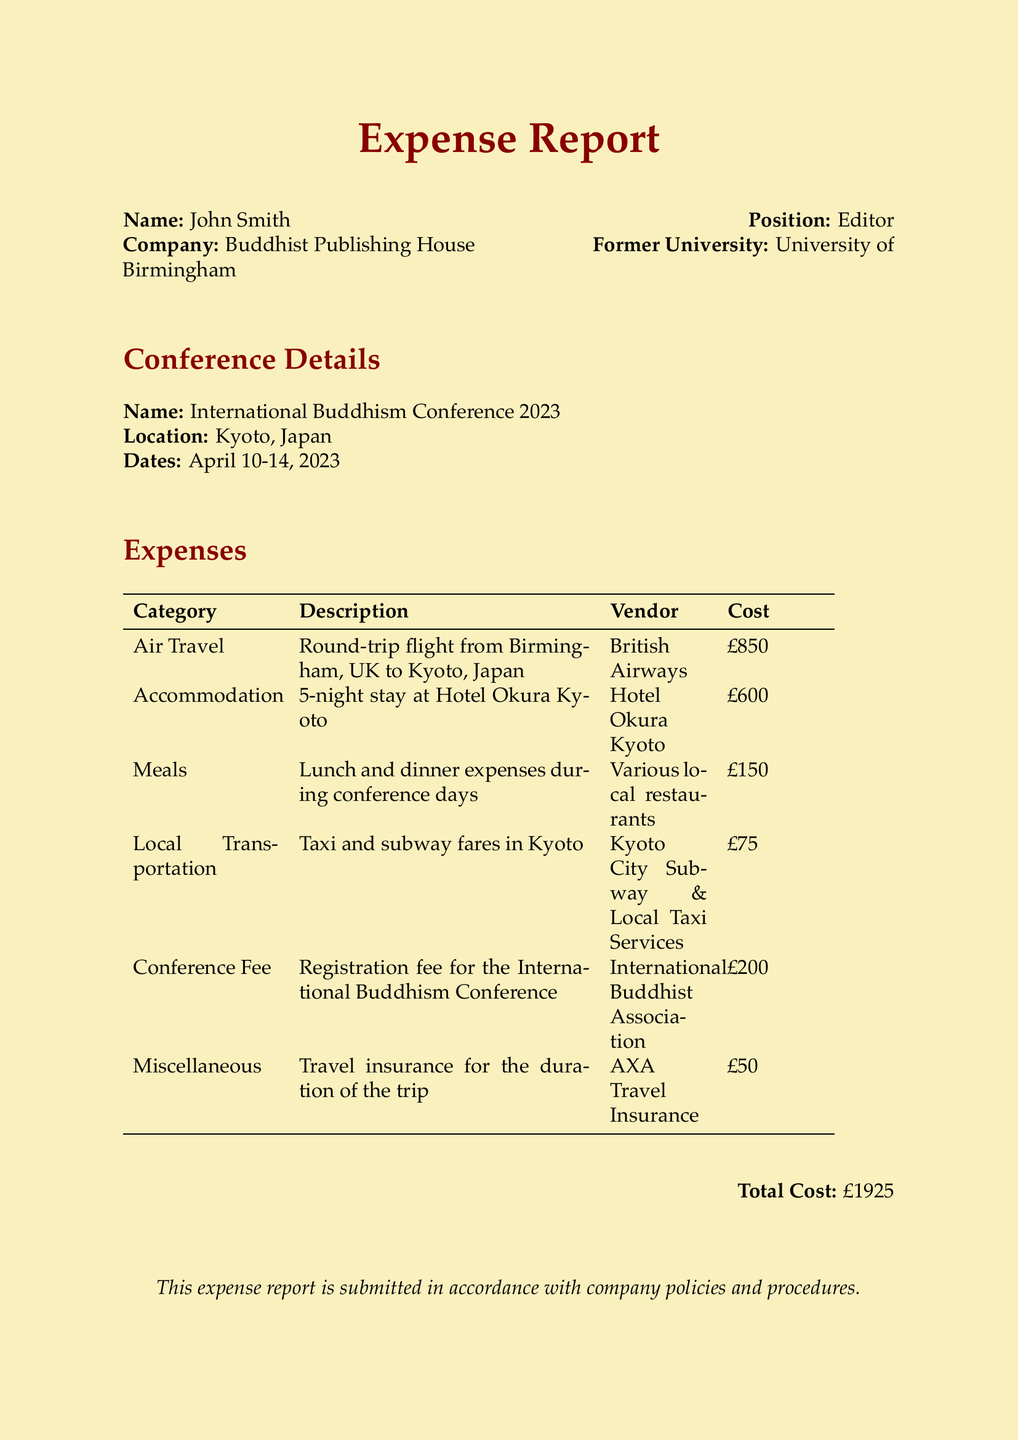What is the total cost of the trip? The total cost is provided at the bottom of the expense report as the sum of all individual expenses.
Answer: £1925 Who is the vendor for the air travel? The vendor listed for the air travel expense in the table is British Airways.
Answer: British Airways How many nights was the accommodation stay? The document specifies a 5-night stay at the hotel, which can be found in the Accommodation section.
Answer: 5 nights What is the cost of the conference fee? The cost of the conference fee is listed in the Expenses table under Conference Fee.
Answer: £200 What type of travel insurance was purchased? The document states that the miscellaneous expense was for travel insurance, which was acquired from AXA Travel Insurance.
Answer: AXA Travel Insurance On which dates did the conference take place? The conference dates are detailed in the Conference Details section as April 10-14, 2023.
Answer: April 10-14, 2023 What is the name of the hotel for accommodation? The hotel for accommodation is mentioned in the Expenses table under the Accommodation cost description.
Answer: Hotel Okura Kyoto Which restaurants were used for meals? The document indicates that meal expenses were incurred at various local restaurants during the conference.
Answer: Various local restaurants What was the main purpose of this document? The purpose of the document is to report and itemize travel expenses incurred for attending a specific conference.
Answer: Expense report 